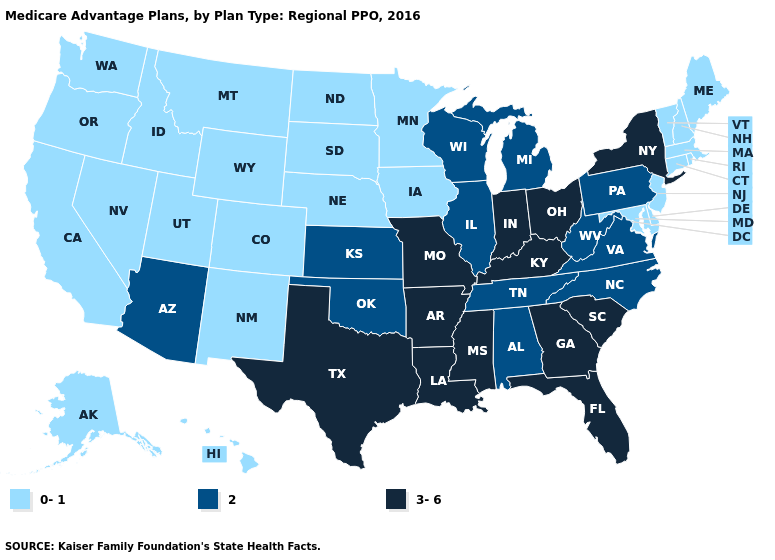Which states hav the highest value in the West?
Quick response, please. Arizona. What is the lowest value in the South?
Answer briefly. 0-1. Does Arizona have the lowest value in the West?
Write a very short answer. No. Among the states that border Mississippi , which have the lowest value?
Keep it brief. Alabama, Tennessee. Name the states that have a value in the range 2?
Be succinct. Alabama, Arizona, Illinois, Kansas, Michigan, North Carolina, Oklahoma, Pennsylvania, Tennessee, Virginia, Wisconsin, West Virginia. Name the states that have a value in the range 2?
Keep it brief. Alabama, Arizona, Illinois, Kansas, Michigan, North Carolina, Oklahoma, Pennsylvania, Tennessee, Virginia, Wisconsin, West Virginia. What is the highest value in states that border Mississippi?
Write a very short answer. 3-6. Which states have the lowest value in the USA?
Give a very brief answer. Alaska, California, Colorado, Connecticut, Delaware, Hawaii, Iowa, Idaho, Massachusetts, Maryland, Maine, Minnesota, Montana, North Dakota, Nebraska, New Hampshire, New Jersey, New Mexico, Nevada, Oregon, Rhode Island, South Dakota, Utah, Vermont, Washington, Wyoming. Among the states that border Florida , does Georgia have the lowest value?
Be succinct. No. Does Texas have the same value as Rhode Island?
Be succinct. No. Does the map have missing data?
Keep it brief. No. What is the value of Nebraska?
Be succinct. 0-1. Does the first symbol in the legend represent the smallest category?
Give a very brief answer. Yes. What is the value of Kansas?
Concise answer only. 2. What is the highest value in states that border South Carolina?
Short answer required. 3-6. 